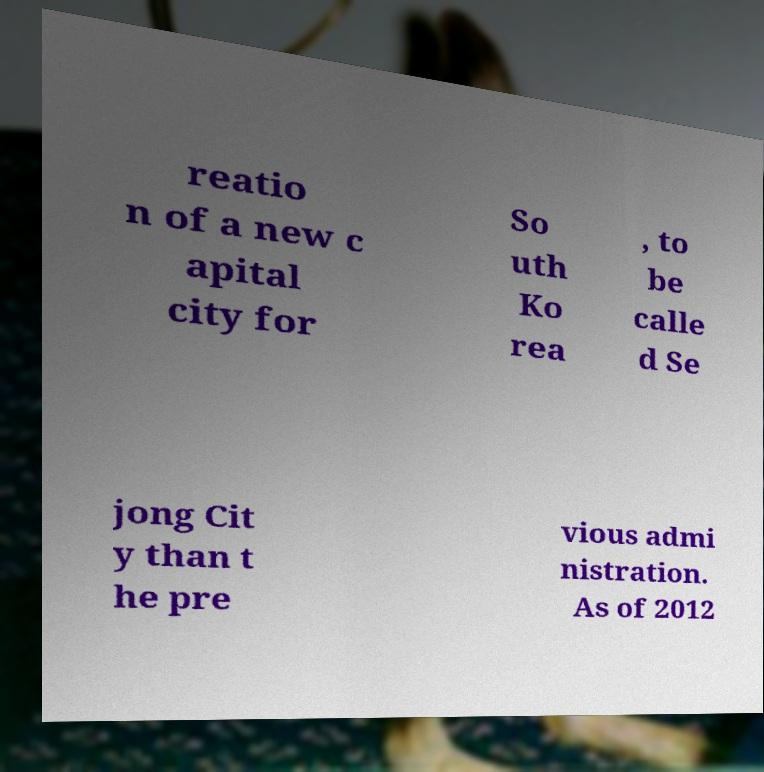Could you extract and type out the text from this image? reatio n of a new c apital city for So uth Ko rea , to be calle d Se jong Cit y than t he pre vious admi nistration. As of 2012 